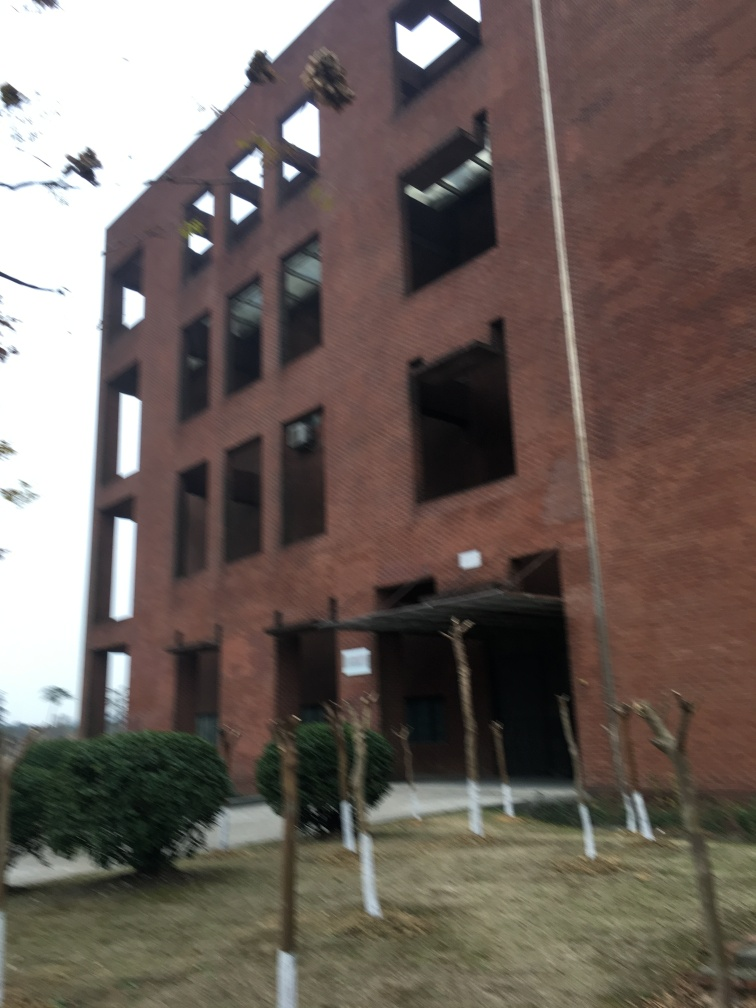What can we infer about the condition and use of the building shown? The building seems unoccupied or in a state of disrepair, with some windows appearing dark and missing panes of glass. This condition might indicate that it's currently not in use or perhaps undergoing renovation. 